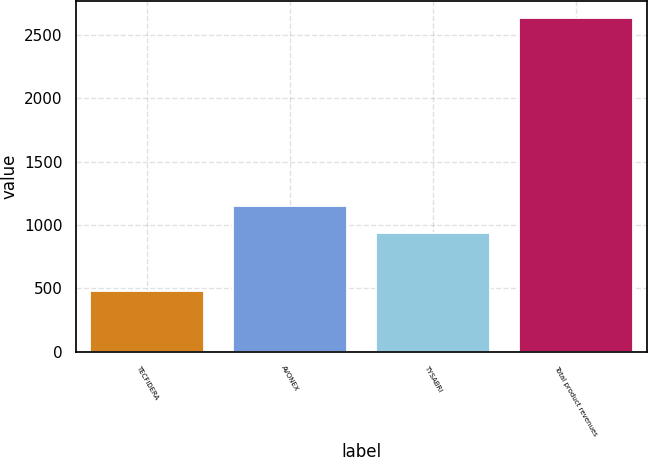Convert chart. <chart><loc_0><loc_0><loc_500><loc_500><bar_chart><fcel>TECFIDERA<fcel>AVONEX<fcel>TYSABRI<fcel>Total product revenues<nl><fcel>482.6<fcel>1149.81<fcel>934.4<fcel>2636.7<nl></chart> 